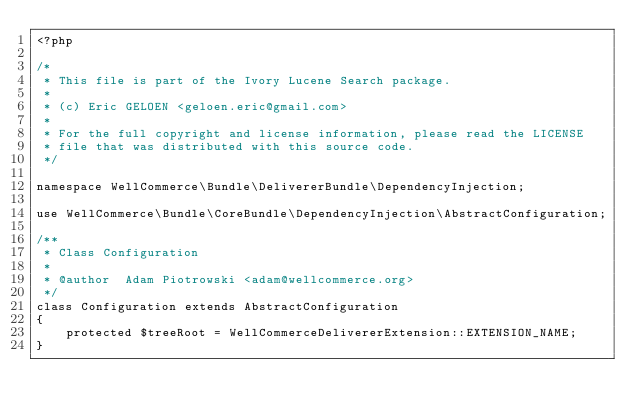<code> <loc_0><loc_0><loc_500><loc_500><_PHP_><?php

/*
 * This file is part of the Ivory Lucene Search package.
 *
 * (c) Eric GELOEN <geloen.eric@gmail.com>
 *
 * For the full copyright and license information, please read the LICENSE
 * file that was distributed with this source code.
 */

namespace WellCommerce\Bundle\DelivererBundle\DependencyInjection;

use WellCommerce\Bundle\CoreBundle\DependencyInjection\AbstractConfiguration;

/**
 * Class Configuration
 *
 * @author  Adam Piotrowski <adam@wellcommerce.org>
 */
class Configuration extends AbstractConfiguration
{
    protected $treeRoot = WellCommerceDelivererExtension::EXTENSION_NAME;
}
</code> 